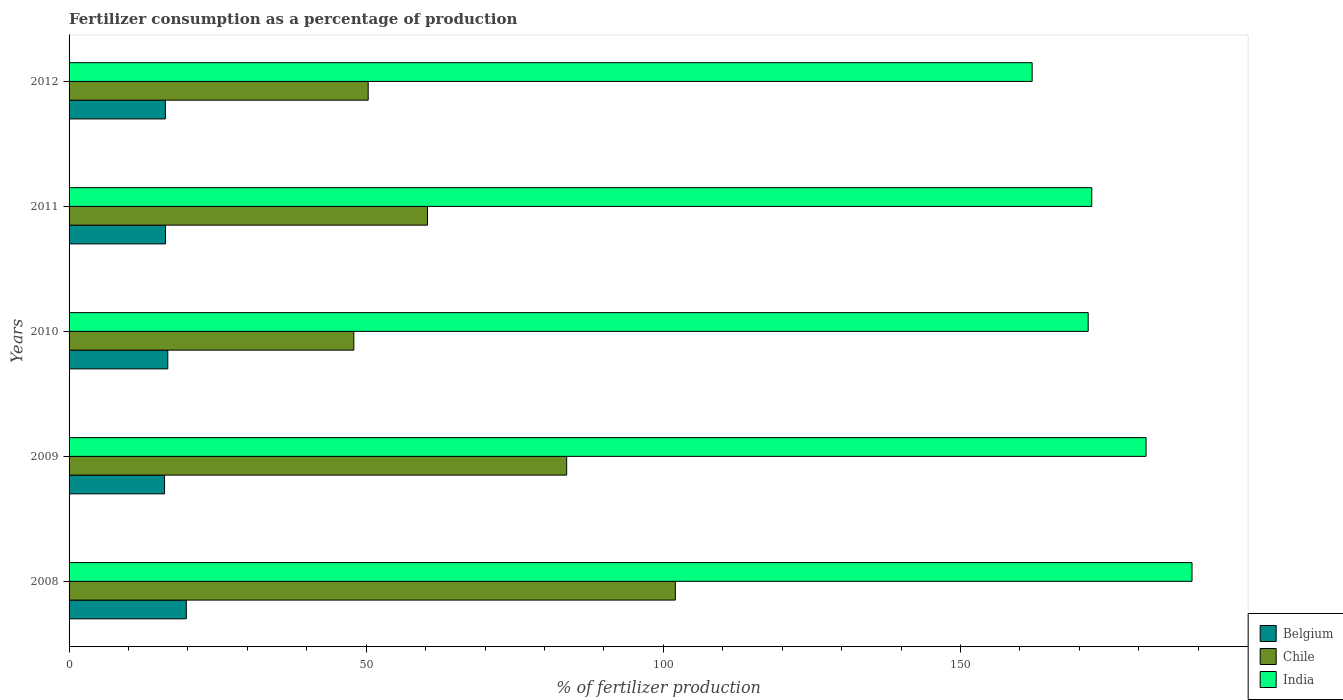How many different coloured bars are there?
Your answer should be compact. 3. How many groups of bars are there?
Keep it short and to the point. 5. Are the number of bars on each tick of the Y-axis equal?
Provide a succinct answer. Yes. How many bars are there on the 3rd tick from the top?
Your answer should be compact. 3. How many bars are there on the 3rd tick from the bottom?
Offer a very short reply. 3. In how many cases, is the number of bars for a given year not equal to the number of legend labels?
Your answer should be compact. 0. What is the percentage of fertilizers consumed in Belgium in 2011?
Give a very brief answer. 16.23. Across all years, what is the maximum percentage of fertilizers consumed in Chile?
Make the answer very short. 102.02. Across all years, what is the minimum percentage of fertilizers consumed in Chile?
Offer a very short reply. 47.92. In which year was the percentage of fertilizers consumed in Belgium maximum?
Give a very brief answer. 2008. What is the total percentage of fertilizers consumed in Belgium in the graph?
Keep it short and to the point. 84.85. What is the difference between the percentage of fertilizers consumed in India in 2009 and that in 2010?
Offer a very short reply. 9.74. What is the difference between the percentage of fertilizers consumed in India in 2011 and the percentage of fertilizers consumed in Belgium in 2008?
Offer a terse response. 152.36. What is the average percentage of fertilizers consumed in Chile per year?
Offer a very short reply. 68.86. In the year 2010, what is the difference between the percentage of fertilizers consumed in India and percentage of fertilizers consumed in Chile?
Offer a very short reply. 123.57. In how many years, is the percentage of fertilizers consumed in India greater than 30 %?
Offer a terse response. 5. What is the ratio of the percentage of fertilizers consumed in India in 2009 to that in 2010?
Your answer should be compact. 1.06. Is the percentage of fertilizers consumed in Belgium in 2009 less than that in 2011?
Offer a terse response. Yes. What is the difference between the highest and the second highest percentage of fertilizers consumed in Belgium?
Your answer should be very brief. 3.12. What is the difference between the highest and the lowest percentage of fertilizers consumed in India?
Your response must be concise. 26.9. In how many years, is the percentage of fertilizers consumed in Belgium greater than the average percentage of fertilizers consumed in Belgium taken over all years?
Offer a very short reply. 1. Is the sum of the percentage of fertilizers consumed in Chile in 2008 and 2011 greater than the maximum percentage of fertilizers consumed in Belgium across all years?
Offer a very short reply. Yes. What does the 2nd bar from the top in 2012 represents?
Give a very brief answer. Chile. Is it the case that in every year, the sum of the percentage of fertilizers consumed in India and percentage of fertilizers consumed in Belgium is greater than the percentage of fertilizers consumed in Chile?
Offer a very short reply. Yes. How many bars are there?
Give a very brief answer. 15. What is the difference between two consecutive major ticks on the X-axis?
Keep it short and to the point. 50. Are the values on the major ticks of X-axis written in scientific E-notation?
Offer a terse response. No. How are the legend labels stacked?
Offer a terse response. Vertical. What is the title of the graph?
Offer a terse response. Fertilizer consumption as a percentage of production. What is the label or title of the X-axis?
Your answer should be very brief. % of fertilizer production. What is the label or title of the Y-axis?
Keep it short and to the point. Years. What is the % of fertilizer production of Belgium in 2008?
Offer a terse response. 19.73. What is the % of fertilizer production in Chile in 2008?
Offer a very short reply. 102.02. What is the % of fertilizer production in India in 2008?
Your answer should be very brief. 188.97. What is the % of fertilizer production in Belgium in 2009?
Your answer should be compact. 16.07. What is the % of fertilizer production in Chile in 2009?
Provide a short and direct response. 83.73. What is the % of fertilizer production in India in 2009?
Keep it short and to the point. 181.23. What is the % of fertilizer production in Belgium in 2010?
Keep it short and to the point. 16.61. What is the % of fertilizer production in Chile in 2010?
Your answer should be compact. 47.92. What is the % of fertilizer production of India in 2010?
Offer a terse response. 171.49. What is the % of fertilizer production of Belgium in 2011?
Your response must be concise. 16.23. What is the % of fertilizer production of Chile in 2011?
Provide a short and direct response. 60.31. What is the % of fertilizer production of India in 2011?
Your answer should be very brief. 172.09. What is the % of fertilizer production of Belgium in 2012?
Provide a succinct answer. 16.21. What is the % of fertilizer production in Chile in 2012?
Your answer should be very brief. 50.33. What is the % of fertilizer production in India in 2012?
Your response must be concise. 162.06. Across all years, what is the maximum % of fertilizer production of Belgium?
Ensure brevity in your answer.  19.73. Across all years, what is the maximum % of fertilizer production of Chile?
Your answer should be compact. 102.02. Across all years, what is the maximum % of fertilizer production of India?
Offer a terse response. 188.97. Across all years, what is the minimum % of fertilizer production of Belgium?
Offer a terse response. 16.07. Across all years, what is the minimum % of fertilizer production in Chile?
Keep it short and to the point. 47.92. Across all years, what is the minimum % of fertilizer production of India?
Your answer should be very brief. 162.06. What is the total % of fertilizer production of Belgium in the graph?
Make the answer very short. 84.85. What is the total % of fertilizer production of Chile in the graph?
Provide a short and direct response. 344.32. What is the total % of fertilizer production of India in the graph?
Your answer should be compact. 875.84. What is the difference between the % of fertilizer production in Belgium in 2008 and that in 2009?
Make the answer very short. 3.66. What is the difference between the % of fertilizer production in Chile in 2008 and that in 2009?
Provide a short and direct response. 18.29. What is the difference between the % of fertilizer production of India in 2008 and that in 2009?
Offer a terse response. 7.73. What is the difference between the % of fertilizer production of Belgium in 2008 and that in 2010?
Keep it short and to the point. 3.12. What is the difference between the % of fertilizer production in Chile in 2008 and that in 2010?
Make the answer very short. 54.1. What is the difference between the % of fertilizer production of India in 2008 and that in 2010?
Make the answer very short. 17.47. What is the difference between the % of fertilizer production in Belgium in 2008 and that in 2011?
Keep it short and to the point. 3.5. What is the difference between the % of fertilizer production of Chile in 2008 and that in 2011?
Your answer should be very brief. 41.71. What is the difference between the % of fertilizer production of India in 2008 and that in 2011?
Ensure brevity in your answer.  16.87. What is the difference between the % of fertilizer production of Belgium in 2008 and that in 2012?
Provide a succinct answer. 3.52. What is the difference between the % of fertilizer production in Chile in 2008 and that in 2012?
Provide a short and direct response. 51.69. What is the difference between the % of fertilizer production in India in 2008 and that in 2012?
Make the answer very short. 26.9. What is the difference between the % of fertilizer production of Belgium in 2009 and that in 2010?
Keep it short and to the point. -0.54. What is the difference between the % of fertilizer production in Chile in 2009 and that in 2010?
Ensure brevity in your answer.  35.81. What is the difference between the % of fertilizer production in India in 2009 and that in 2010?
Keep it short and to the point. 9.74. What is the difference between the % of fertilizer production of Belgium in 2009 and that in 2011?
Provide a succinct answer. -0.16. What is the difference between the % of fertilizer production of Chile in 2009 and that in 2011?
Provide a short and direct response. 23.42. What is the difference between the % of fertilizer production in India in 2009 and that in 2011?
Offer a terse response. 9.14. What is the difference between the % of fertilizer production of Belgium in 2009 and that in 2012?
Offer a terse response. -0.14. What is the difference between the % of fertilizer production in Chile in 2009 and that in 2012?
Keep it short and to the point. 33.4. What is the difference between the % of fertilizer production of India in 2009 and that in 2012?
Offer a very short reply. 19.17. What is the difference between the % of fertilizer production of Belgium in 2010 and that in 2011?
Keep it short and to the point. 0.38. What is the difference between the % of fertilizer production of Chile in 2010 and that in 2011?
Give a very brief answer. -12.39. What is the difference between the % of fertilizer production in India in 2010 and that in 2011?
Ensure brevity in your answer.  -0.6. What is the difference between the % of fertilizer production of Belgium in 2010 and that in 2012?
Your response must be concise. 0.4. What is the difference between the % of fertilizer production of Chile in 2010 and that in 2012?
Offer a very short reply. -2.41. What is the difference between the % of fertilizer production in India in 2010 and that in 2012?
Give a very brief answer. 9.43. What is the difference between the % of fertilizer production of Belgium in 2011 and that in 2012?
Offer a very short reply. 0.02. What is the difference between the % of fertilizer production of Chile in 2011 and that in 2012?
Your answer should be compact. 9.98. What is the difference between the % of fertilizer production of India in 2011 and that in 2012?
Provide a short and direct response. 10.03. What is the difference between the % of fertilizer production in Belgium in 2008 and the % of fertilizer production in Chile in 2009?
Offer a terse response. -64. What is the difference between the % of fertilizer production in Belgium in 2008 and the % of fertilizer production in India in 2009?
Give a very brief answer. -161.5. What is the difference between the % of fertilizer production in Chile in 2008 and the % of fertilizer production in India in 2009?
Your answer should be compact. -79.21. What is the difference between the % of fertilizer production of Belgium in 2008 and the % of fertilizer production of Chile in 2010?
Make the answer very short. -28.19. What is the difference between the % of fertilizer production in Belgium in 2008 and the % of fertilizer production in India in 2010?
Offer a very short reply. -151.76. What is the difference between the % of fertilizer production of Chile in 2008 and the % of fertilizer production of India in 2010?
Your response must be concise. -69.47. What is the difference between the % of fertilizer production of Belgium in 2008 and the % of fertilizer production of Chile in 2011?
Your answer should be very brief. -40.58. What is the difference between the % of fertilizer production in Belgium in 2008 and the % of fertilizer production in India in 2011?
Give a very brief answer. -152.36. What is the difference between the % of fertilizer production of Chile in 2008 and the % of fertilizer production of India in 2011?
Offer a terse response. -70.07. What is the difference between the % of fertilizer production of Belgium in 2008 and the % of fertilizer production of Chile in 2012?
Give a very brief answer. -30.6. What is the difference between the % of fertilizer production in Belgium in 2008 and the % of fertilizer production in India in 2012?
Give a very brief answer. -142.33. What is the difference between the % of fertilizer production of Chile in 2008 and the % of fertilizer production of India in 2012?
Make the answer very short. -60.04. What is the difference between the % of fertilizer production in Belgium in 2009 and the % of fertilizer production in Chile in 2010?
Offer a terse response. -31.85. What is the difference between the % of fertilizer production of Belgium in 2009 and the % of fertilizer production of India in 2010?
Give a very brief answer. -155.42. What is the difference between the % of fertilizer production in Chile in 2009 and the % of fertilizer production in India in 2010?
Offer a very short reply. -87.76. What is the difference between the % of fertilizer production of Belgium in 2009 and the % of fertilizer production of Chile in 2011?
Ensure brevity in your answer.  -44.24. What is the difference between the % of fertilizer production of Belgium in 2009 and the % of fertilizer production of India in 2011?
Make the answer very short. -156.02. What is the difference between the % of fertilizer production in Chile in 2009 and the % of fertilizer production in India in 2011?
Offer a terse response. -88.36. What is the difference between the % of fertilizer production of Belgium in 2009 and the % of fertilizer production of Chile in 2012?
Your response must be concise. -34.26. What is the difference between the % of fertilizer production in Belgium in 2009 and the % of fertilizer production in India in 2012?
Ensure brevity in your answer.  -145.99. What is the difference between the % of fertilizer production in Chile in 2009 and the % of fertilizer production in India in 2012?
Your answer should be very brief. -78.33. What is the difference between the % of fertilizer production of Belgium in 2010 and the % of fertilizer production of Chile in 2011?
Make the answer very short. -43.7. What is the difference between the % of fertilizer production of Belgium in 2010 and the % of fertilizer production of India in 2011?
Keep it short and to the point. -155.48. What is the difference between the % of fertilizer production in Chile in 2010 and the % of fertilizer production in India in 2011?
Offer a very short reply. -124.18. What is the difference between the % of fertilizer production in Belgium in 2010 and the % of fertilizer production in Chile in 2012?
Your answer should be very brief. -33.72. What is the difference between the % of fertilizer production of Belgium in 2010 and the % of fertilizer production of India in 2012?
Provide a short and direct response. -145.45. What is the difference between the % of fertilizer production of Chile in 2010 and the % of fertilizer production of India in 2012?
Keep it short and to the point. -114.14. What is the difference between the % of fertilizer production in Belgium in 2011 and the % of fertilizer production in Chile in 2012?
Offer a terse response. -34.1. What is the difference between the % of fertilizer production in Belgium in 2011 and the % of fertilizer production in India in 2012?
Your response must be concise. -145.83. What is the difference between the % of fertilizer production of Chile in 2011 and the % of fertilizer production of India in 2012?
Provide a succinct answer. -101.75. What is the average % of fertilizer production of Belgium per year?
Keep it short and to the point. 16.97. What is the average % of fertilizer production of Chile per year?
Your answer should be very brief. 68.86. What is the average % of fertilizer production in India per year?
Your answer should be compact. 175.17. In the year 2008, what is the difference between the % of fertilizer production of Belgium and % of fertilizer production of Chile?
Provide a short and direct response. -82.29. In the year 2008, what is the difference between the % of fertilizer production in Belgium and % of fertilizer production in India?
Keep it short and to the point. -169.24. In the year 2008, what is the difference between the % of fertilizer production of Chile and % of fertilizer production of India?
Your response must be concise. -86.94. In the year 2009, what is the difference between the % of fertilizer production in Belgium and % of fertilizer production in Chile?
Offer a terse response. -67.66. In the year 2009, what is the difference between the % of fertilizer production in Belgium and % of fertilizer production in India?
Make the answer very short. -165.16. In the year 2009, what is the difference between the % of fertilizer production of Chile and % of fertilizer production of India?
Your answer should be compact. -97.5. In the year 2010, what is the difference between the % of fertilizer production of Belgium and % of fertilizer production of Chile?
Your answer should be compact. -31.31. In the year 2010, what is the difference between the % of fertilizer production in Belgium and % of fertilizer production in India?
Provide a short and direct response. -154.88. In the year 2010, what is the difference between the % of fertilizer production of Chile and % of fertilizer production of India?
Your response must be concise. -123.57. In the year 2011, what is the difference between the % of fertilizer production in Belgium and % of fertilizer production in Chile?
Your answer should be very brief. -44.08. In the year 2011, what is the difference between the % of fertilizer production in Belgium and % of fertilizer production in India?
Your answer should be very brief. -155.86. In the year 2011, what is the difference between the % of fertilizer production of Chile and % of fertilizer production of India?
Your response must be concise. -111.78. In the year 2012, what is the difference between the % of fertilizer production of Belgium and % of fertilizer production of Chile?
Give a very brief answer. -34.13. In the year 2012, what is the difference between the % of fertilizer production in Belgium and % of fertilizer production in India?
Your answer should be very brief. -145.86. In the year 2012, what is the difference between the % of fertilizer production of Chile and % of fertilizer production of India?
Make the answer very short. -111.73. What is the ratio of the % of fertilizer production of Belgium in 2008 to that in 2009?
Your answer should be compact. 1.23. What is the ratio of the % of fertilizer production of Chile in 2008 to that in 2009?
Keep it short and to the point. 1.22. What is the ratio of the % of fertilizer production of India in 2008 to that in 2009?
Provide a succinct answer. 1.04. What is the ratio of the % of fertilizer production of Belgium in 2008 to that in 2010?
Keep it short and to the point. 1.19. What is the ratio of the % of fertilizer production of Chile in 2008 to that in 2010?
Provide a succinct answer. 2.13. What is the ratio of the % of fertilizer production of India in 2008 to that in 2010?
Provide a succinct answer. 1.1. What is the ratio of the % of fertilizer production of Belgium in 2008 to that in 2011?
Offer a terse response. 1.22. What is the ratio of the % of fertilizer production of Chile in 2008 to that in 2011?
Make the answer very short. 1.69. What is the ratio of the % of fertilizer production of India in 2008 to that in 2011?
Provide a succinct answer. 1.1. What is the ratio of the % of fertilizer production in Belgium in 2008 to that in 2012?
Provide a succinct answer. 1.22. What is the ratio of the % of fertilizer production in Chile in 2008 to that in 2012?
Your response must be concise. 2.03. What is the ratio of the % of fertilizer production of India in 2008 to that in 2012?
Provide a succinct answer. 1.17. What is the ratio of the % of fertilizer production of Belgium in 2009 to that in 2010?
Your response must be concise. 0.97. What is the ratio of the % of fertilizer production of Chile in 2009 to that in 2010?
Keep it short and to the point. 1.75. What is the ratio of the % of fertilizer production in India in 2009 to that in 2010?
Offer a very short reply. 1.06. What is the ratio of the % of fertilizer production of Chile in 2009 to that in 2011?
Your answer should be very brief. 1.39. What is the ratio of the % of fertilizer production of India in 2009 to that in 2011?
Offer a terse response. 1.05. What is the ratio of the % of fertilizer production of Chile in 2009 to that in 2012?
Offer a terse response. 1.66. What is the ratio of the % of fertilizer production in India in 2009 to that in 2012?
Offer a terse response. 1.12. What is the ratio of the % of fertilizer production in Belgium in 2010 to that in 2011?
Your answer should be compact. 1.02. What is the ratio of the % of fertilizer production of Chile in 2010 to that in 2011?
Give a very brief answer. 0.79. What is the ratio of the % of fertilizer production of Belgium in 2010 to that in 2012?
Keep it short and to the point. 1.02. What is the ratio of the % of fertilizer production of Chile in 2010 to that in 2012?
Offer a terse response. 0.95. What is the ratio of the % of fertilizer production of India in 2010 to that in 2012?
Give a very brief answer. 1.06. What is the ratio of the % of fertilizer production of Belgium in 2011 to that in 2012?
Make the answer very short. 1. What is the ratio of the % of fertilizer production of Chile in 2011 to that in 2012?
Keep it short and to the point. 1.2. What is the ratio of the % of fertilizer production of India in 2011 to that in 2012?
Make the answer very short. 1.06. What is the difference between the highest and the second highest % of fertilizer production in Belgium?
Offer a terse response. 3.12. What is the difference between the highest and the second highest % of fertilizer production in Chile?
Make the answer very short. 18.29. What is the difference between the highest and the second highest % of fertilizer production of India?
Ensure brevity in your answer.  7.73. What is the difference between the highest and the lowest % of fertilizer production in Belgium?
Provide a succinct answer. 3.66. What is the difference between the highest and the lowest % of fertilizer production of Chile?
Offer a very short reply. 54.1. What is the difference between the highest and the lowest % of fertilizer production of India?
Keep it short and to the point. 26.9. 